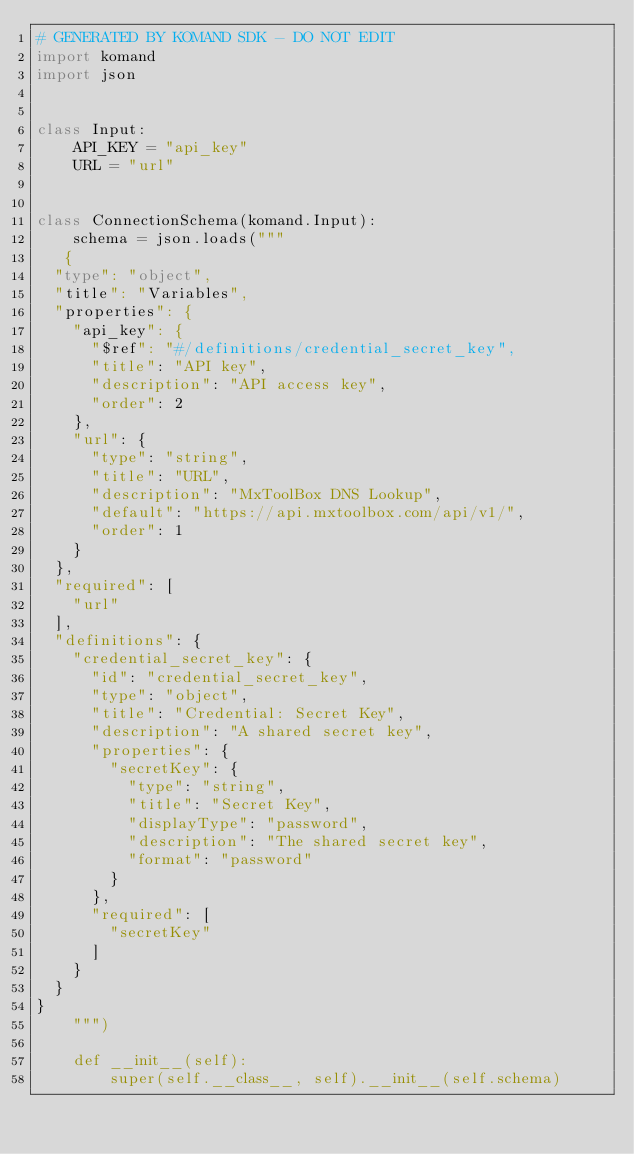<code> <loc_0><loc_0><loc_500><loc_500><_Python_># GENERATED BY KOMAND SDK - DO NOT EDIT
import komand
import json


class Input:
    API_KEY = "api_key"
    URL = "url"
    

class ConnectionSchema(komand.Input):
    schema = json.loads("""
   {
  "type": "object",
  "title": "Variables",
  "properties": {
    "api_key": {
      "$ref": "#/definitions/credential_secret_key",
      "title": "API key",
      "description": "API access key",
      "order": 2
    },
    "url": {
      "type": "string",
      "title": "URL",
      "description": "MxToolBox DNS Lookup",
      "default": "https://api.mxtoolbox.com/api/v1/",
      "order": 1
    }
  },
  "required": [
    "url"
  ],
  "definitions": {
    "credential_secret_key": {
      "id": "credential_secret_key",
      "type": "object",
      "title": "Credential: Secret Key",
      "description": "A shared secret key",
      "properties": {
        "secretKey": {
          "type": "string",
          "title": "Secret Key",
          "displayType": "password",
          "description": "The shared secret key",
          "format": "password"
        }
      },
      "required": [
        "secretKey"
      ]
    }
  }
}
    """)

    def __init__(self):
        super(self.__class__, self).__init__(self.schema)
</code> 